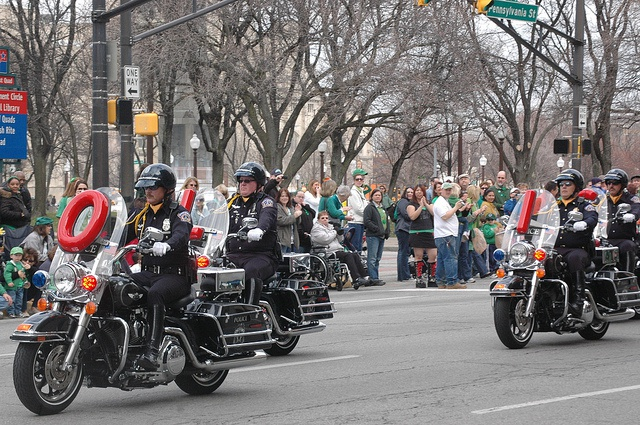Describe the objects in this image and their specific colors. I can see motorcycle in white, black, gray, darkgray, and lightgray tones, people in white, black, gray, darkgray, and lightgray tones, motorcycle in white, black, gray, darkgray, and lightgray tones, people in white, black, gray, darkgray, and lightgray tones, and motorcycle in white, black, gray, darkgray, and lightgray tones in this image. 